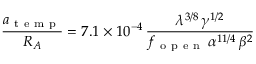Convert formula to latex. <formula><loc_0><loc_0><loc_500><loc_500>\frac { a _ { t e m p } } { R _ { A } } = 7 . 1 \times 1 0 ^ { - 4 } \, \frac { \lambda ^ { 3 / 8 } \, \gamma ^ { 1 / 2 } } { f _ { o p e n } \, \alpha ^ { 1 1 / 4 } \, \beta ^ { 2 } }</formula> 